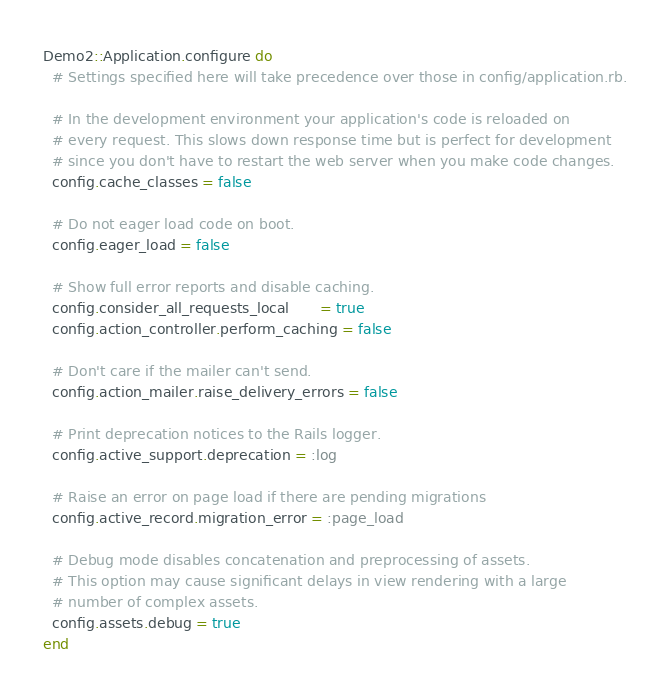<code> <loc_0><loc_0><loc_500><loc_500><_Ruby_>Demo2::Application.configure do
  # Settings specified here will take precedence over those in config/application.rb.

  # In the development environment your application's code is reloaded on
  # every request. This slows down response time but is perfect for development
  # since you don't have to restart the web server when you make code changes.
  config.cache_classes = false

  # Do not eager load code on boot.
  config.eager_load = false

  # Show full error reports and disable caching.
  config.consider_all_requests_local       = true
  config.action_controller.perform_caching = false

  # Don't care if the mailer can't send.
  config.action_mailer.raise_delivery_errors = false

  # Print deprecation notices to the Rails logger.
  config.active_support.deprecation = :log

  # Raise an error on page load if there are pending migrations
  config.active_record.migration_error = :page_load

  # Debug mode disables concatenation and preprocessing of assets.
  # This option may cause significant delays in view rendering with a large
  # number of complex assets.
  config.assets.debug = true
end
</code> 